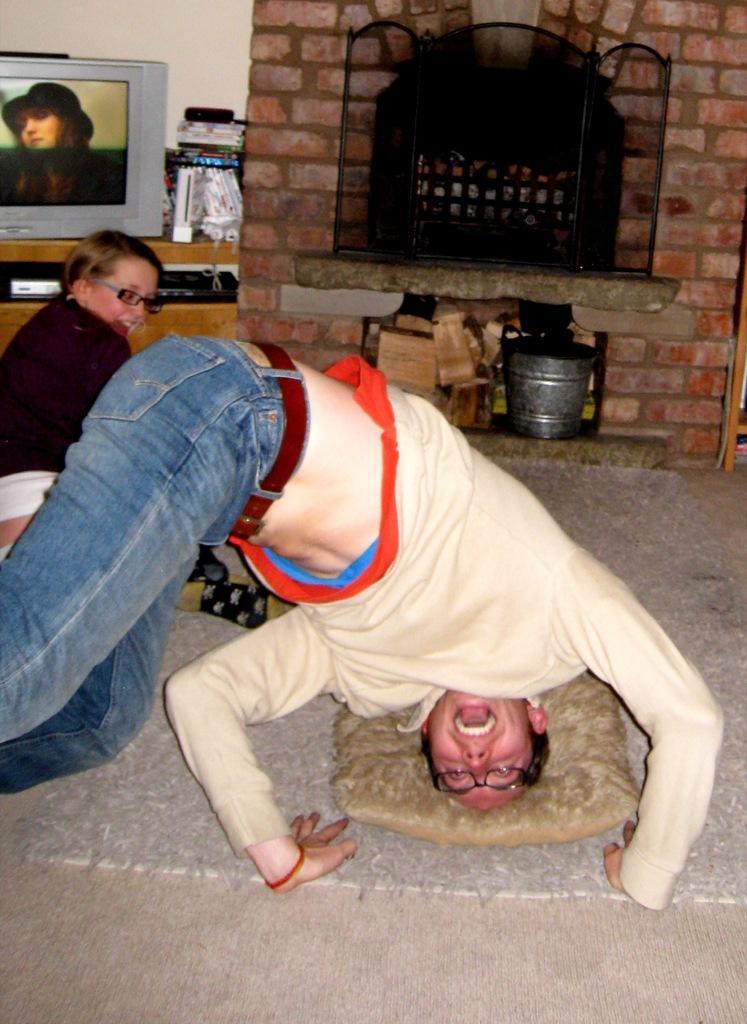Can you describe this image briefly? In this picture there is a person placed his head on a pillow which is on the ground and there is a woman sitting beside him and there is a television placed on a table in the left corner and there are some other objects placed beside it and there is a fire place in the background. 